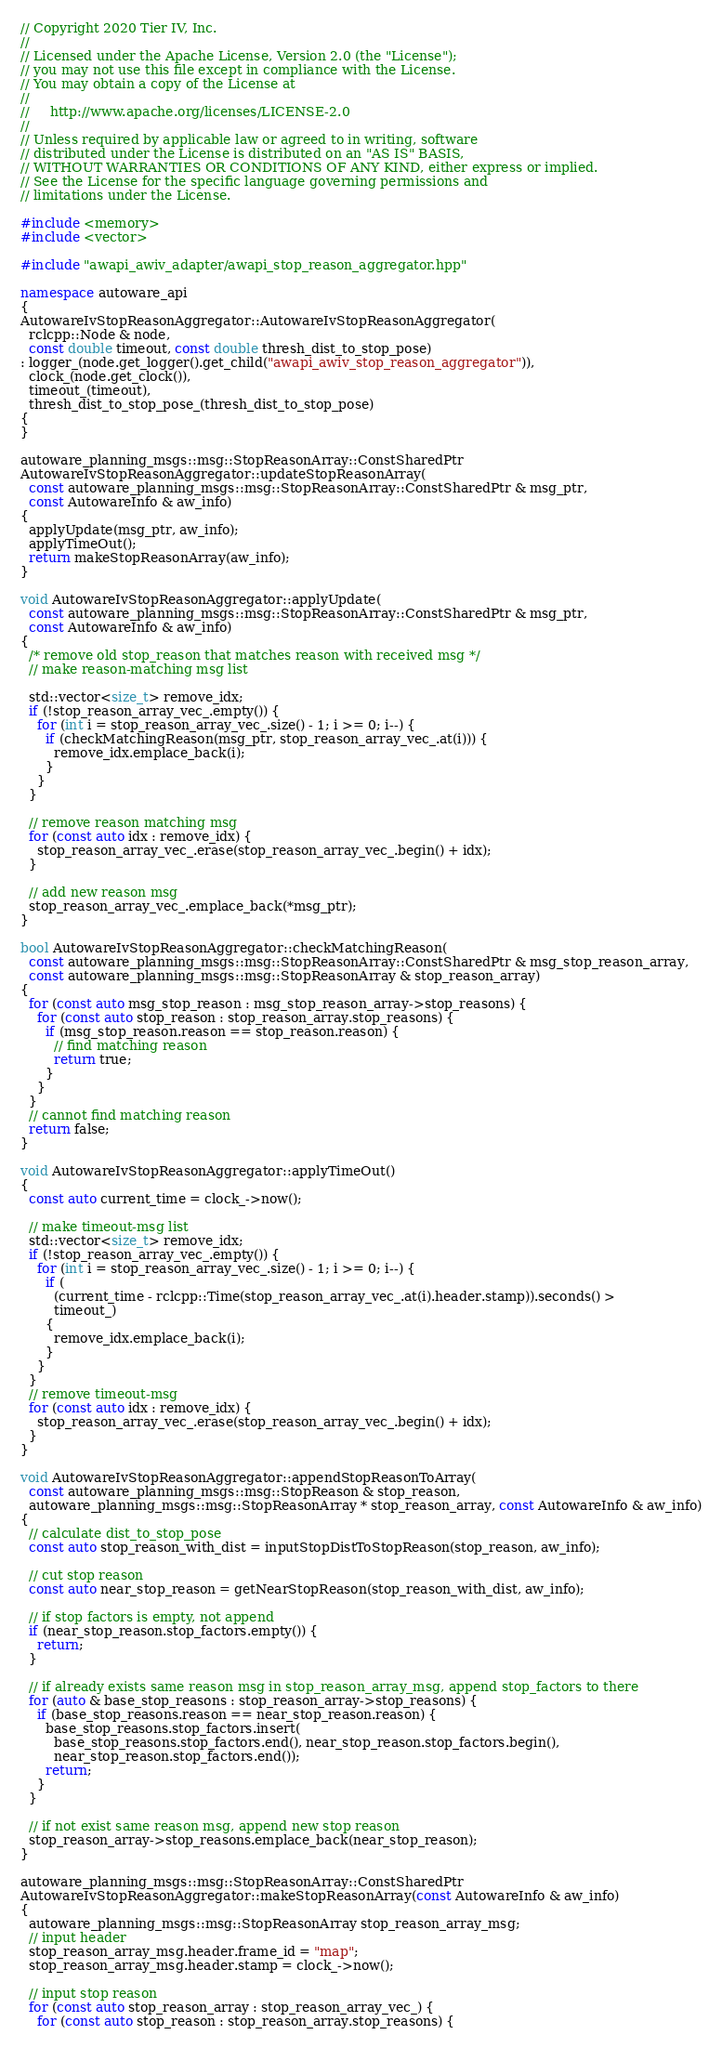<code> <loc_0><loc_0><loc_500><loc_500><_C++_>// Copyright 2020 Tier IV, Inc.
//
// Licensed under the Apache License, Version 2.0 (the "License");
// you may not use this file except in compliance with the License.
// You may obtain a copy of the License at
//
//     http://www.apache.org/licenses/LICENSE-2.0
//
// Unless required by applicable law or agreed to in writing, software
// distributed under the License is distributed on an "AS IS" BASIS,
// WITHOUT WARRANTIES OR CONDITIONS OF ANY KIND, either express or implied.
// See the License for the specific language governing permissions and
// limitations under the License.

#include <memory>
#include <vector>

#include "awapi_awiv_adapter/awapi_stop_reason_aggregator.hpp"

namespace autoware_api
{
AutowareIvStopReasonAggregator::AutowareIvStopReasonAggregator(
  rclcpp::Node & node,
  const double timeout, const double thresh_dist_to_stop_pose)
: logger_(node.get_logger().get_child("awapi_awiv_stop_reason_aggregator")),
  clock_(node.get_clock()),
  timeout_(timeout),
  thresh_dist_to_stop_pose_(thresh_dist_to_stop_pose)
{
}

autoware_planning_msgs::msg::StopReasonArray::ConstSharedPtr
AutowareIvStopReasonAggregator::updateStopReasonArray(
  const autoware_planning_msgs::msg::StopReasonArray::ConstSharedPtr & msg_ptr,
  const AutowareInfo & aw_info)
{
  applyUpdate(msg_ptr, aw_info);
  applyTimeOut();
  return makeStopReasonArray(aw_info);
}

void AutowareIvStopReasonAggregator::applyUpdate(
  const autoware_planning_msgs::msg::StopReasonArray::ConstSharedPtr & msg_ptr,
  const AutowareInfo & aw_info)
{
  /* remove old stop_reason that matches reason with received msg */
  // make reason-matching msg list

  std::vector<size_t> remove_idx;
  if (!stop_reason_array_vec_.empty()) {
    for (int i = stop_reason_array_vec_.size() - 1; i >= 0; i--) {
      if (checkMatchingReason(msg_ptr, stop_reason_array_vec_.at(i))) {
        remove_idx.emplace_back(i);
      }
    }
  }

  // remove reason matching msg
  for (const auto idx : remove_idx) {
    stop_reason_array_vec_.erase(stop_reason_array_vec_.begin() + idx);
  }

  // add new reason msg
  stop_reason_array_vec_.emplace_back(*msg_ptr);
}

bool AutowareIvStopReasonAggregator::checkMatchingReason(
  const autoware_planning_msgs::msg::StopReasonArray::ConstSharedPtr & msg_stop_reason_array,
  const autoware_planning_msgs::msg::StopReasonArray & stop_reason_array)
{
  for (const auto msg_stop_reason : msg_stop_reason_array->stop_reasons) {
    for (const auto stop_reason : stop_reason_array.stop_reasons) {
      if (msg_stop_reason.reason == stop_reason.reason) {
        // find matching reason
        return true;
      }
    }
  }
  // cannot find matching reason
  return false;
}

void AutowareIvStopReasonAggregator::applyTimeOut()
{
  const auto current_time = clock_->now();

  // make timeout-msg list
  std::vector<size_t> remove_idx;
  if (!stop_reason_array_vec_.empty()) {
    for (int i = stop_reason_array_vec_.size() - 1; i >= 0; i--) {
      if (
        (current_time - rclcpp::Time(stop_reason_array_vec_.at(i).header.stamp)).seconds() >
        timeout_)
      {
        remove_idx.emplace_back(i);
      }
    }
  }
  // remove timeout-msg
  for (const auto idx : remove_idx) {
    stop_reason_array_vec_.erase(stop_reason_array_vec_.begin() + idx);
  }
}

void AutowareIvStopReasonAggregator::appendStopReasonToArray(
  const autoware_planning_msgs::msg::StopReason & stop_reason,
  autoware_planning_msgs::msg::StopReasonArray * stop_reason_array, const AutowareInfo & aw_info)
{
  // calculate dist_to_stop_pose
  const auto stop_reason_with_dist = inputStopDistToStopReason(stop_reason, aw_info);

  // cut stop reason
  const auto near_stop_reason = getNearStopReason(stop_reason_with_dist, aw_info);

  // if stop factors is empty, not append
  if (near_stop_reason.stop_factors.empty()) {
    return;
  }

  // if already exists same reason msg in stop_reason_array_msg, append stop_factors to there
  for (auto & base_stop_reasons : stop_reason_array->stop_reasons) {
    if (base_stop_reasons.reason == near_stop_reason.reason) {
      base_stop_reasons.stop_factors.insert(
        base_stop_reasons.stop_factors.end(), near_stop_reason.stop_factors.begin(),
        near_stop_reason.stop_factors.end());
      return;
    }
  }

  // if not exist same reason msg, append new stop reason
  stop_reason_array->stop_reasons.emplace_back(near_stop_reason);
}

autoware_planning_msgs::msg::StopReasonArray::ConstSharedPtr
AutowareIvStopReasonAggregator::makeStopReasonArray(const AutowareInfo & aw_info)
{
  autoware_planning_msgs::msg::StopReasonArray stop_reason_array_msg;
  // input header
  stop_reason_array_msg.header.frame_id = "map";
  stop_reason_array_msg.header.stamp = clock_->now();

  // input stop reason
  for (const auto stop_reason_array : stop_reason_array_vec_) {
    for (const auto stop_reason : stop_reason_array.stop_reasons) {</code> 